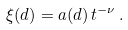Convert formula to latex. <formula><loc_0><loc_0><loc_500><loc_500>\xi ( d ) = a ( d ) \, t ^ { - \nu } \, .</formula> 